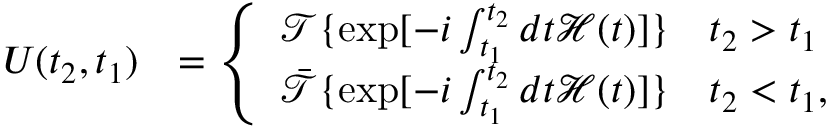<formula> <loc_0><loc_0><loc_500><loc_500>\begin{array} { r l } { U ( t _ { 2 } , t _ { 1 } ) } & { = \left \{ \begin{array} { l l } { \mathcal { T } \{ \exp [ - i \int _ { t _ { 1 } } ^ { t _ { 2 } } d t \mathcal { H } ( t ) ] \} \quad t _ { 2 } > t _ { 1 } } \\ { \ B a r { \mathcal { T } } \{ \exp [ - i \int _ { t _ { 1 } } ^ { t _ { 2 } } d t \mathcal { H } ( t ) ] \} \quad t _ { 2 } < t _ { 1 } , } \end{array} } \end{array}</formula> 